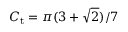Convert formula to latex. <formula><loc_0><loc_0><loc_500><loc_500>C _ { t } = \pi ( 3 + \sqrt { 2 } ) / 7</formula> 